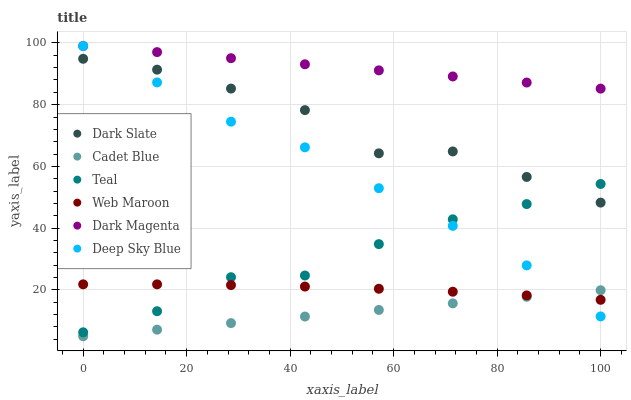Does Cadet Blue have the minimum area under the curve?
Answer yes or no. Yes. Does Dark Magenta have the maximum area under the curve?
Answer yes or no. Yes. Does Web Maroon have the minimum area under the curve?
Answer yes or no. No. Does Web Maroon have the maximum area under the curve?
Answer yes or no. No. Is Dark Magenta the smoothest?
Answer yes or no. Yes. Is Dark Slate the roughest?
Answer yes or no. Yes. Is Web Maroon the smoothest?
Answer yes or no. No. Is Web Maroon the roughest?
Answer yes or no. No. Does Cadet Blue have the lowest value?
Answer yes or no. Yes. Does Web Maroon have the lowest value?
Answer yes or no. No. Does Deep Sky Blue have the highest value?
Answer yes or no. Yes. Does Web Maroon have the highest value?
Answer yes or no. No. Is Dark Slate less than Dark Magenta?
Answer yes or no. Yes. Is Dark Magenta greater than Web Maroon?
Answer yes or no. Yes. Does Teal intersect Web Maroon?
Answer yes or no. Yes. Is Teal less than Web Maroon?
Answer yes or no. No. Is Teal greater than Web Maroon?
Answer yes or no. No. Does Dark Slate intersect Dark Magenta?
Answer yes or no. No. 